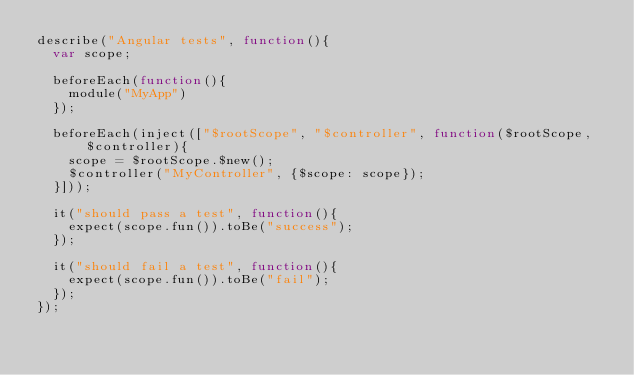<code> <loc_0><loc_0><loc_500><loc_500><_JavaScript_>describe("Angular tests", function(){
  var scope;

  beforeEach(function(){
    module("MyApp")
  });

  beforeEach(inject(["$rootScope", "$controller", function($rootScope, $controller){
    scope = $rootScope.$new();
    $controller("MyController", {$scope: scope});
  }]));

  it("should pass a test", function(){
    expect(scope.fun()).toBe("success");
  });

  it("should fail a test", function(){
    expect(scope.fun()).toBe("fail");
  });
});</code> 